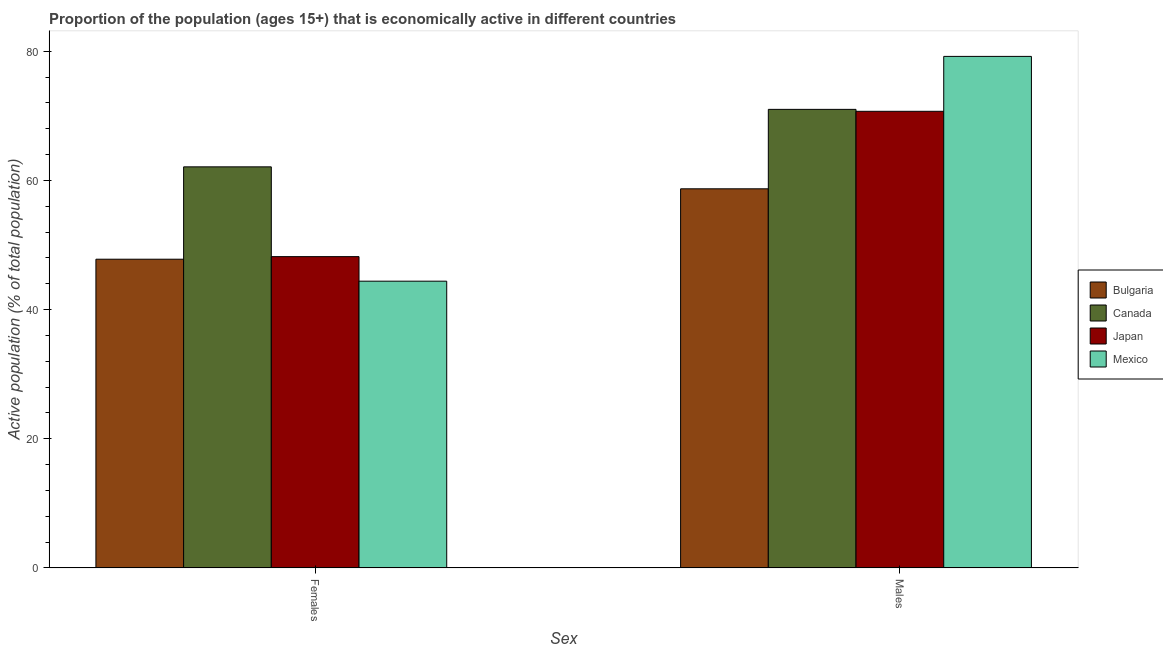Are the number of bars per tick equal to the number of legend labels?
Your answer should be compact. Yes. Are the number of bars on each tick of the X-axis equal?
Your response must be concise. Yes. How many bars are there on the 1st tick from the left?
Ensure brevity in your answer.  4. How many bars are there on the 1st tick from the right?
Make the answer very short. 4. What is the label of the 1st group of bars from the left?
Give a very brief answer. Females. What is the percentage of economically active male population in Canada?
Offer a very short reply. 71. Across all countries, what is the maximum percentage of economically active male population?
Provide a short and direct response. 79.2. Across all countries, what is the minimum percentage of economically active female population?
Make the answer very short. 44.4. In which country was the percentage of economically active male population maximum?
Offer a very short reply. Mexico. In which country was the percentage of economically active male population minimum?
Ensure brevity in your answer.  Bulgaria. What is the total percentage of economically active female population in the graph?
Offer a terse response. 202.5. What is the difference between the percentage of economically active female population in Japan and that in Mexico?
Offer a very short reply. 3.8. What is the difference between the percentage of economically active male population in Japan and the percentage of economically active female population in Mexico?
Give a very brief answer. 26.3. What is the average percentage of economically active female population per country?
Offer a very short reply. 50.62. What is the difference between the percentage of economically active female population and percentage of economically active male population in Bulgaria?
Offer a terse response. -10.9. In how many countries, is the percentage of economically active male population greater than 44 %?
Your answer should be compact. 4. What is the ratio of the percentage of economically active male population in Japan to that in Bulgaria?
Make the answer very short. 1.2. In how many countries, is the percentage of economically active female population greater than the average percentage of economically active female population taken over all countries?
Offer a terse response. 1. What does the 2nd bar from the left in Males represents?
Ensure brevity in your answer.  Canada. What is the difference between two consecutive major ticks on the Y-axis?
Provide a succinct answer. 20. Are the values on the major ticks of Y-axis written in scientific E-notation?
Offer a very short reply. No. Does the graph contain any zero values?
Give a very brief answer. No. Where does the legend appear in the graph?
Make the answer very short. Center right. How are the legend labels stacked?
Offer a terse response. Vertical. What is the title of the graph?
Provide a short and direct response. Proportion of the population (ages 15+) that is economically active in different countries. Does "United Kingdom" appear as one of the legend labels in the graph?
Provide a succinct answer. No. What is the label or title of the X-axis?
Your answer should be compact. Sex. What is the label or title of the Y-axis?
Keep it short and to the point. Active population (% of total population). What is the Active population (% of total population) of Bulgaria in Females?
Your answer should be very brief. 47.8. What is the Active population (% of total population) in Canada in Females?
Your answer should be very brief. 62.1. What is the Active population (% of total population) in Japan in Females?
Offer a terse response. 48.2. What is the Active population (% of total population) in Mexico in Females?
Keep it short and to the point. 44.4. What is the Active population (% of total population) of Bulgaria in Males?
Ensure brevity in your answer.  58.7. What is the Active population (% of total population) of Canada in Males?
Offer a terse response. 71. What is the Active population (% of total population) of Japan in Males?
Give a very brief answer. 70.7. What is the Active population (% of total population) of Mexico in Males?
Your answer should be very brief. 79.2. Across all Sex, what is the maximum Active population (% of total population) in Bulgaria?
Make the answer very short. 58.7. Across all Sex, what is the maximum Active population (% of total population) of Canada?
Give a very brief answer. 71. Across all Sex, what is the maximum Active population (% of total population) of Japan?
Your answer should be compact. 70.7. Across all Sex, what is the maximum Active population (% of total population) of Mexico?
Offer a very short reply. 79.2. Across all Sex, what is the minimum Active population (% of total population) in Bulgaria?
Your answer should be compact. 47.8. Across all Sex, what is the minimum Active population (% of total population) of Canada?
Provide a short and direct response. 62.1. Across all Sex, what is the minimum Active population (% of total population) of Japan?
Provide a succinct answer. 48.2. Across all Sex, what is the minimum Active population (% of total population) of Mexico?
Your answer should be very brief. 44.4. What is the total Active population (% of total population) in Bulgaria in the graph?
Your answer should be very brief. 106.5. What is the total Active population (% of total population) of Canada in the graph?
Provide a short and direct response. 133.1. What is the total Active population (% of total population) in Japan in the graph?
Your answer should be very brief. 118.9. What is the total Active population (% of total population) of Mexico in the graph?
Provide a short and direct response. 123.6. What is the difference between the Active population (% of total population) of Bulgaria in Females and that in Males?
Keep it short and to the point. -10.9. What is the difference between the Active population (% of total population) of Japan in Females and that in Males?
Your answer should be very brief. -22.5. What is the difference between the Active population (% of total population) in Mexico in Females and that in Males?
Your answer should be compact. -34.8. What is the difference between the Active population (% of total population) in Bulgaria in Females and the Active population (% of total population) in Canada in Males?
Your answer should be very brief. -23.2. What is the difference between the Active population (% of total population) of Bulgaria in Females and the Active population (% of total population) of Japan in Males?
Give a very brief answer. -22.9. What is the difference between the Active population (% of total population) of Bulgaria in Females and the Active population (% of total population) of Mexico in Males?
Give a very brief answer. -31.4. What is the difference between the Active population (% of total population) of Canada in Females and the Active population (% of total population) of Mexico in Males?
Offer a very short reply. -17.1. What is the difference between the Active population (% of total population) of Japan in Females and the Active population (% of total population) of Mexico in Males?
Offer a terse response. -31. What is the average Active population (% of total population) in Bulgaria per Sex?
Keep it short and to the point. 53.25. What is the average Active population (% of total population) in Canada per Sex?
Your answer should be compact. 66.55. What is the average Active population (% of total population) in Japan per Sex?
Offer a terse response. 59.45. What is the average Active population (% of total population) in Mexico per Sex?
Your response must be concise. 61.8. What is the difference between the Active population (% of total population) of Bulgaria and Active population (% of total population) of Canada in Females?
Ensure brevity in your answer.  -14.3. What is the difference between the Active population (% of total population) in Bulgaria and Active population (% of total population) in Japan in Females?
Your answer should be compact. -0.4. What is the difference between the Active population (% of total population) of Canada and Active population (% of total population) of Japan in Females?
Keep it short and to the point. 13.9. What is the difference between the Active population (% of total population) in Canada and Active population (% of total population) in Mexico in Females?
Provide a succinct answer. 17.7. What is the difference between the Active population (% of total population) of Bulgaria and Active population (% of total population) of Japan in Males?
Make the answer very short. -12. What is the difference between the Active population (% of total population) of Bulgaria and Active population (% of total population) of Mexico in Males?
Ensure brevity in your answer.  -20.5. What is the difference between the Active population (% of total population) in Canada and Active population (% of total population) in Mexico in Males?
Make the answer very short. -8.2. What is the ratio of the Active population (% of total population) of Bulgaria in Females to that in Males?
Your answer should be compact. 0.81. What is the ratio of the Active population (% of total population) of Canada in Females to that in Males?
Offer a very short reply. 0.87. What is the ratio of the Active population (% of total population) of Japan in Females to that in Males?
Provide a succinct answer. 0.68. What is the ratio of the Active population (% of total population) in Mexico in Females to that in Males?
Make the answer very short. 0.56. What is the difference between the highest and the second highest Active population (% of total population) in Japan?
Offer a terse response. 22.5. What is the difference between the highest and the second highest Active population (% of total population) of Mexico?
Your answer should be compact. 34.8. What is the difference between the highest and the lowest Active population (% of total population) in Bulgaria?
Offer a terse response. 10.9. What is the difference between the highest and the lowest Active population (% of total population) of Canada?
Provide a short and direct response. 8.9. What is the difference between the highest and the lowest Active population (% of total population) in Mexico?
Offer a very short reply. 34.8. 